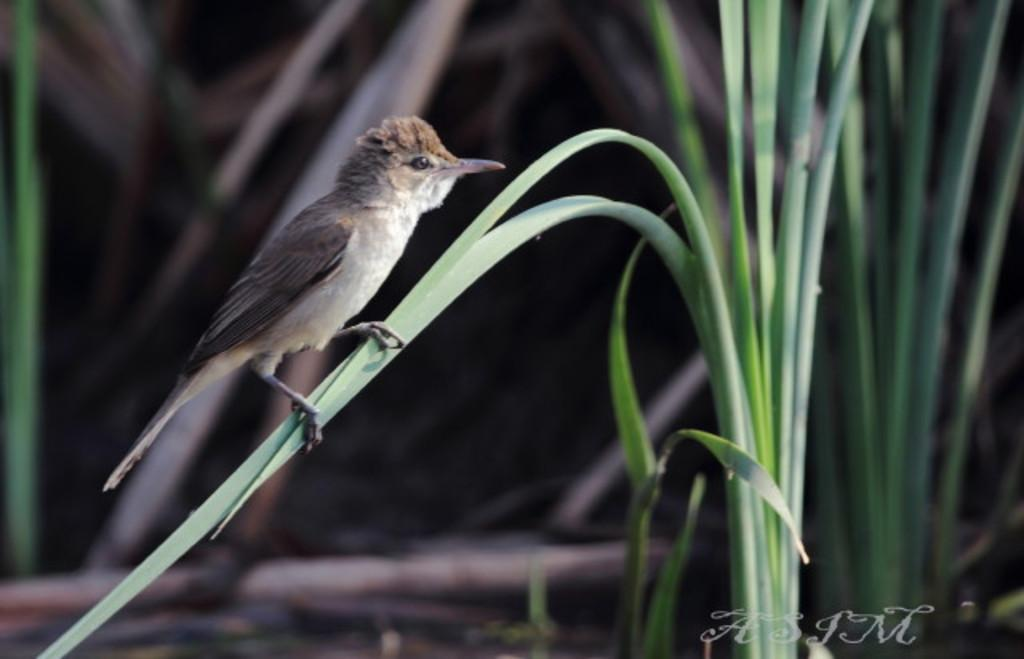What type of animal can be seen in the image? There is a bird in the image. Where is the bird located? The bird is on a plant. How many passengers can be seen in the image? There are no passengers present in the image; it features a bird on a plant. What type of snake is coiled around the bird in the image? There is no snake present in the image; it only features a bird on a plant. 